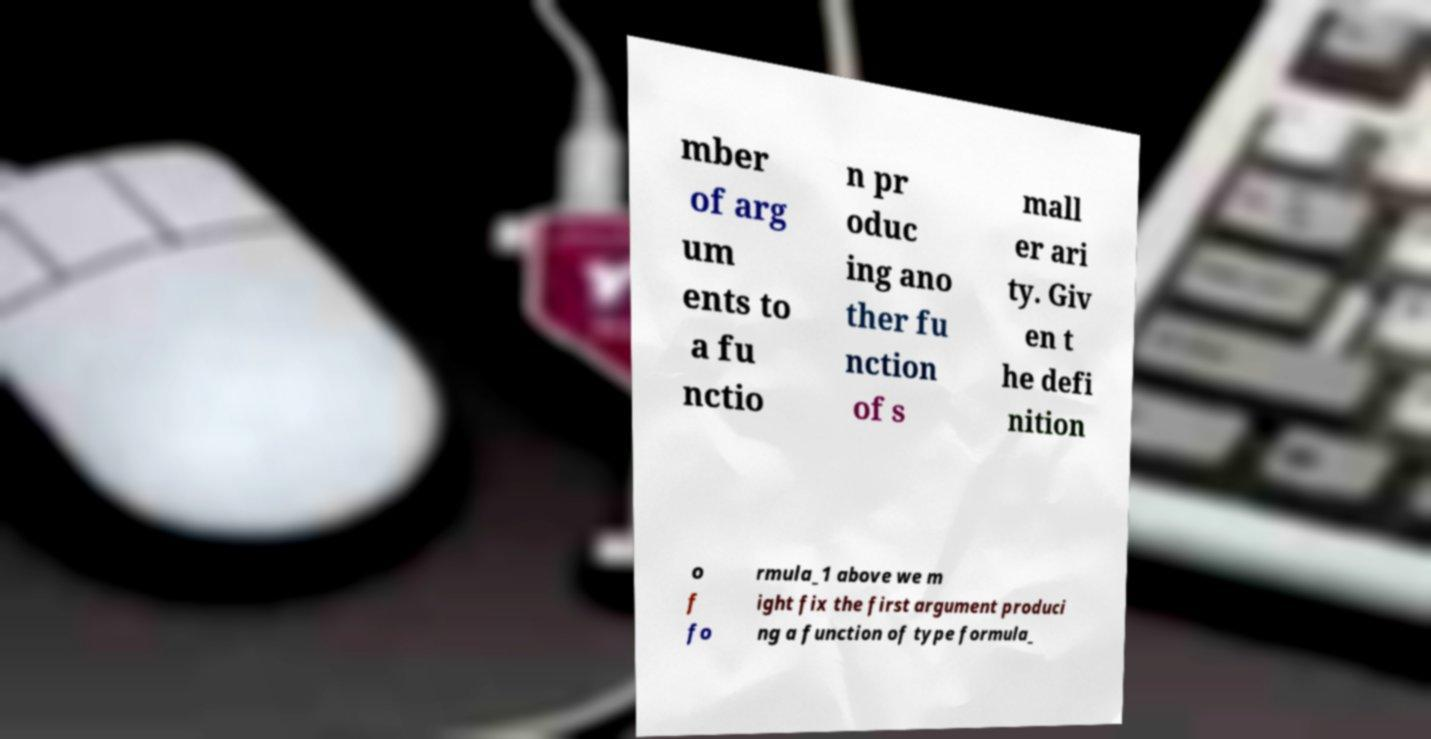Could you extract and type out the text from this image? mber of arg um ents to a fu nctio n pr oduc ing ano ther fu nction of s mall er ari ty. Giv en t he defi nition o f fo rmula_1 above we m ight fix the first argument produci ng a function of type formula_ 